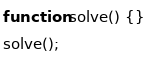Convert code to text. <code><loc_0><loc_0><loc_500><loc_500><_JavaScript_>function solve() {}
solve();
</code> 